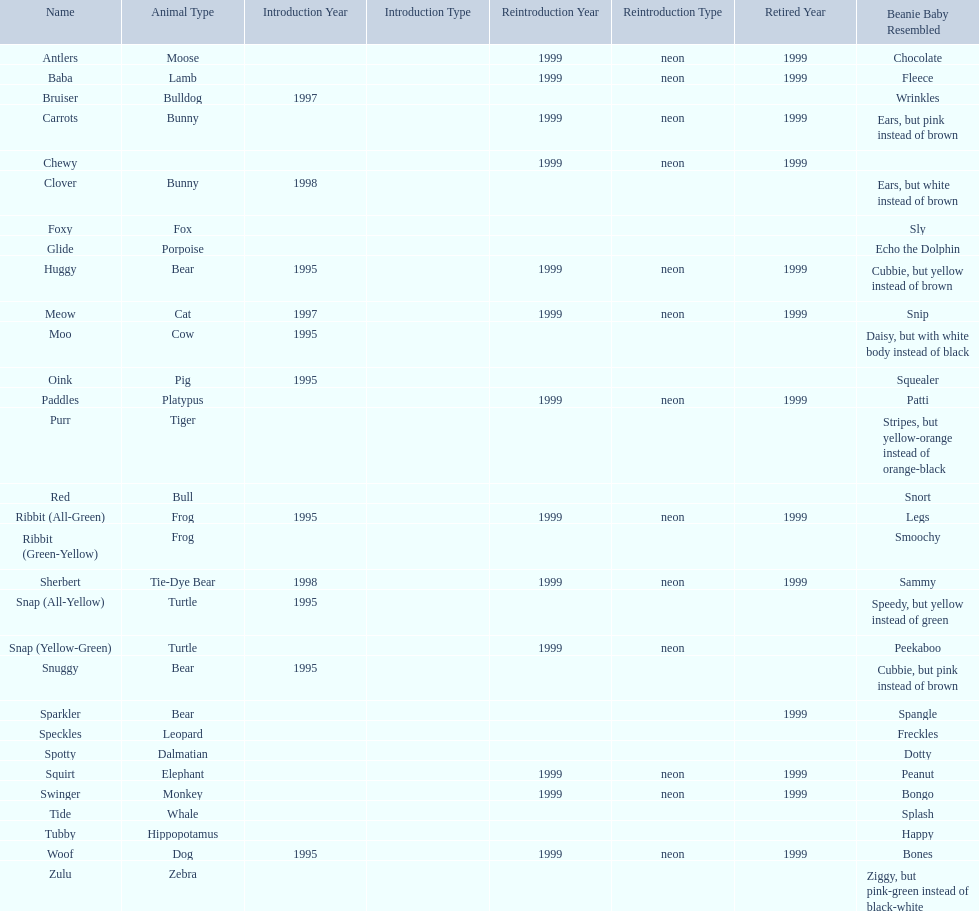What are all the pillow pals? Antlers, Baba, Bruiser, Carrots, Chewy, Clover, Foxy, Glide, Huggy, Meow, Moo, Oink, Paddles, Purr, Red, Ribbit (All-Green), Ribbit (Green-Yellow), Sherbert, Snap (All-Yellow), Snap (Yellow-Green), Snuggy, Sparkler, Speckles, Spotty, Squirt, Swinger, Tide, Tubby, Woof, Zulu. Which is the only without a listed animal type? Chewy. 